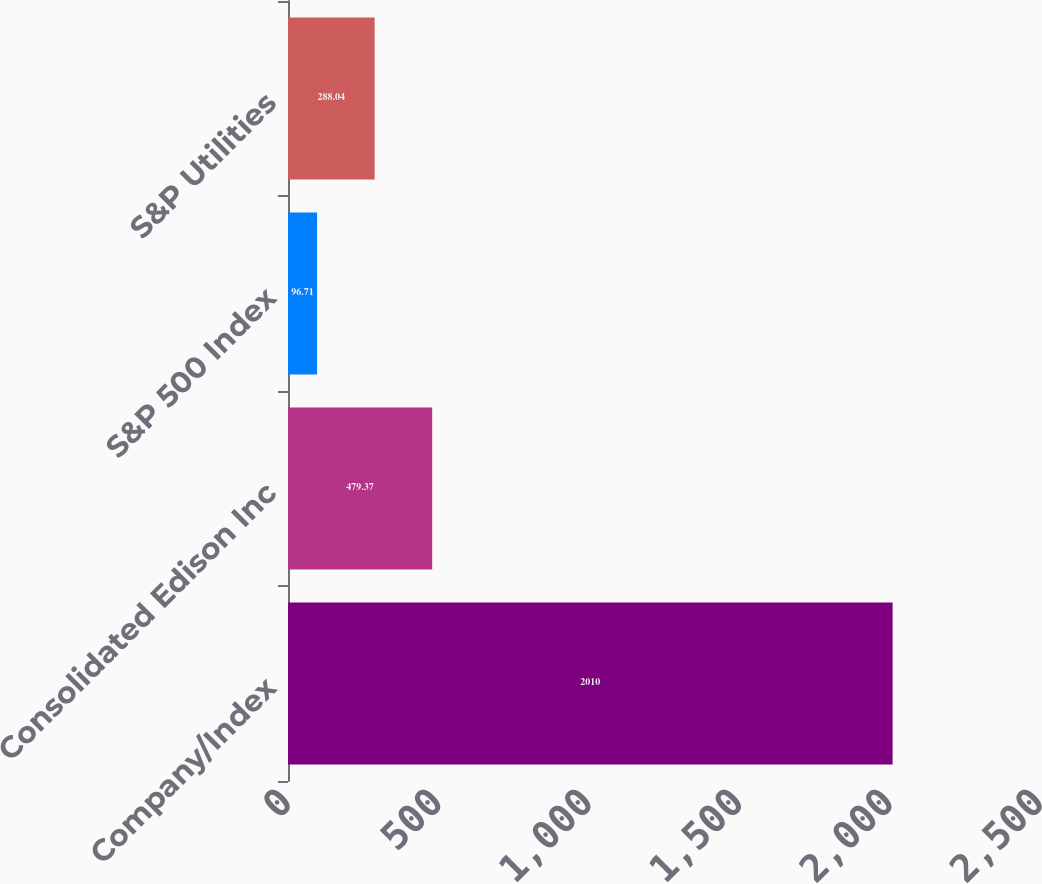Convert chart to OTSL. <chart><loc_0><loc_0><loc_500><loc_500><bar_chart><fcel>Company/Index<fcel>Consolidated Edison Inc<fcel>S&P 500 Index<fcel>S&P Utilities<nl><fcel>2010<fcel>479.37<fcel>96.71<fcel>288.04<nl></chart> 